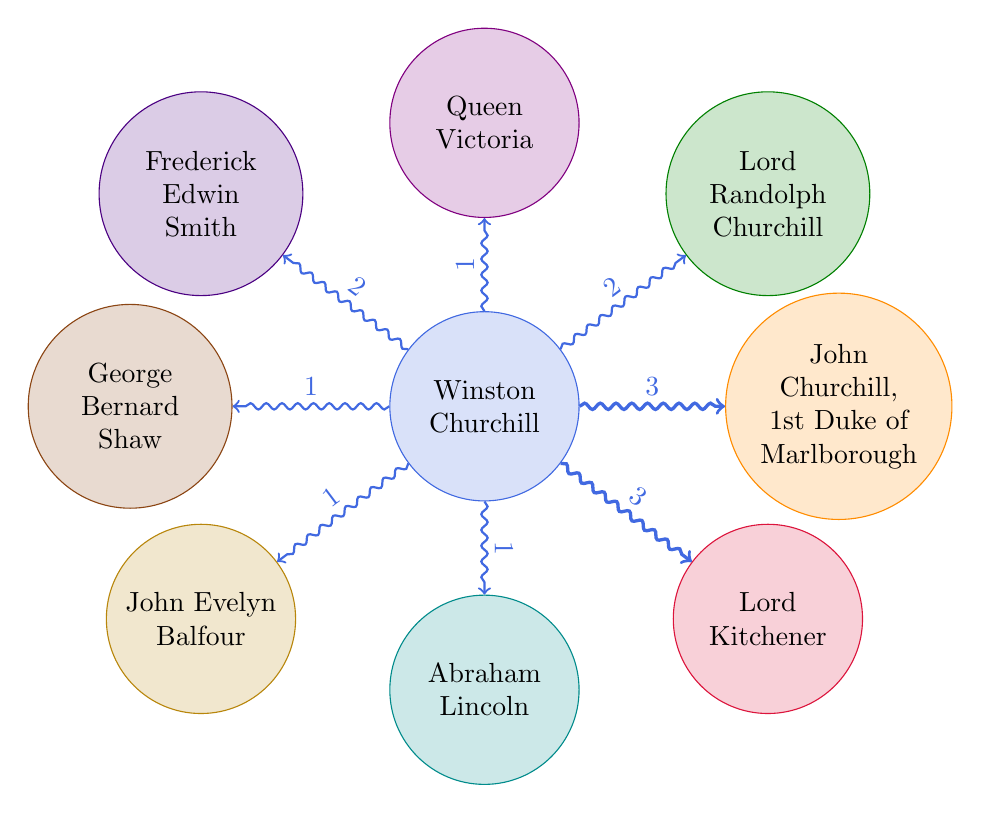What is the value connecting Winston Churchill to Lord Randolph Churchill? The value indicates the strength or significance of the connection, which is represented as "2" in the diagram.
Answer: 2 How many nodes are there in the diagram? The nodes are the entities depicted in the diagram, which includes Winston Churchill and seven historical figures, totaling eight nodes.
Answer: 8 Which historical figure has the strongest connection to Winston Churchill? By examining the link values, John Churchill, 1st Duke of Marlborough and Lord Kitchener both have the highest value of "3," indicating the strongest connections.
Answer: John Churchill, 1st Duke of Marlborough and Lord Kitchener How many connections does Winston Churchill have? Counting the edges leading from Winston Churchill in the diagram reveals a total of seven connections to different historical figures.
Answer: 7 Which historical figure has the weakest connection to Winston Churchill? The value of "1" is the lowest link strength, which applies to Queen Victoria, Abraham Lincoln, John Evelyn Balfour, and George Bernard Shaw, indicating their weak connections.
Answer: Queen Victoria, Abraham Lincoln, John Evelyn Balfour, and George Bernard Shaw What connects Winston Churchill to Lord Kitchener? The connection value of "3" represents a strong relationship between Winston Churchill and Lord Kitchener in the diagram.
Answer: 3 Is there more than one historical figure connected to Winston Churchill with a value of 2? Checking the diagram shows that there is only one historical figure connected to Winston Churchill with a value of "2," which is Lord Randolph Churchill and Frederick Edwin Smith.
Answer: Yes, Lord Randolph Churchill and Frederick Edwin Smith What is the total value of connections Winston Churchill has with John Churchill, 1st Duke of Marlborough and Lord Kitchener? Both have a connection value of "3," so adding them together gives a total value of "6" for these connections.
Answer: 6 